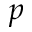<formula> <loc_0><loc_0><loc_500><loc_500>p</formula> 